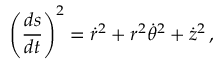<formula> <loc_0><loc_0><loc_500><loc_500>\left ( { \frac { d s } { d t } } \right ) ^ { 2 } = { \dot { r } } ^ { 2 } + r ^ { 2 } { \dot { \theta } } ^ { 2 } + { \dot { z } } ^ { 2 } \, ,</formula> 